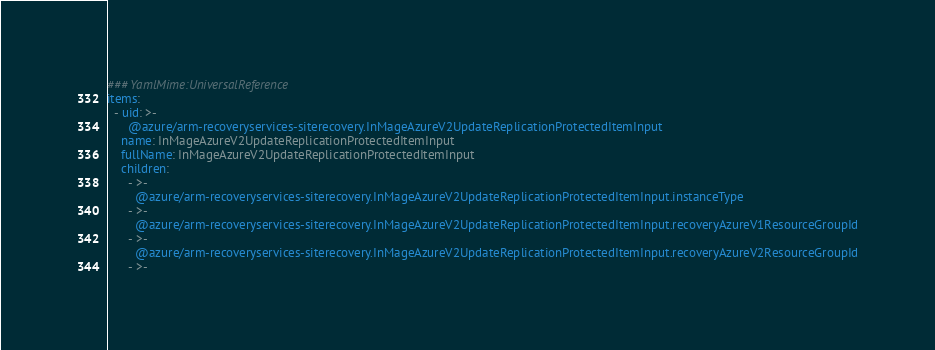<code> <loc_0><loc_0><loc_500><loc_500><_YAML_>### YamlMime:UniversalReference
items:
  - uid: >-
      @azure/arm-recoveryservices-siterecovery.InMageAzureV2UpdateReplicationProtectedItemInput
    name: InMageAzureV2UpdateReplicationProtectedItemInput
    fullName: InMageAzureV2UpdateReplicationProtectedItemInput
    children:
      - >-
        @azure/arm-recoveryservices-siterecovery.InMageAzureV2UpdateReplicationProtectedItemInput.instanceType
      - >-
        @azure/arm-recoveryservices-siterecovery.InMageAzureV2UpdateReplicationProtectedItemInput.recoveryAzureV1ResourceGroupId
      - >-
        @azure/arm-recoveryservices-siterecovery.InMageAzureV2UpdateReplicationProtectedItemInput.recoveryAzureV2ResourceGroupId
      - >-</code> 